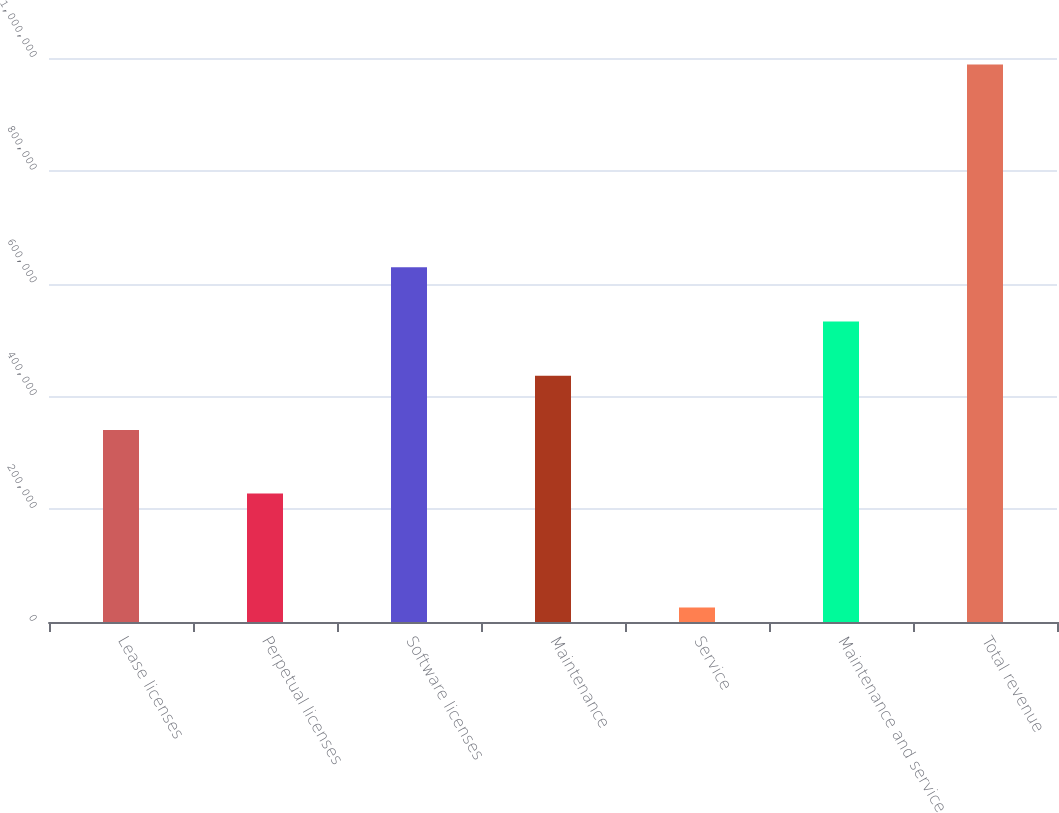<chart> <loc_0><loc_0><loc_500><loc_500><bar_chart><fcel>Lease licenses<fcel>Perpetual licenses<fcel>Software licenses<fcel>Maintenance<fcel>Service<fcel>Maintenance and service<fcel>Total revenue<nl><fcel>340331<fcel>227843<fcel>629207<fcel>436623<fcel>25546<fcel>532915<fcel>988465<nl></chart> 